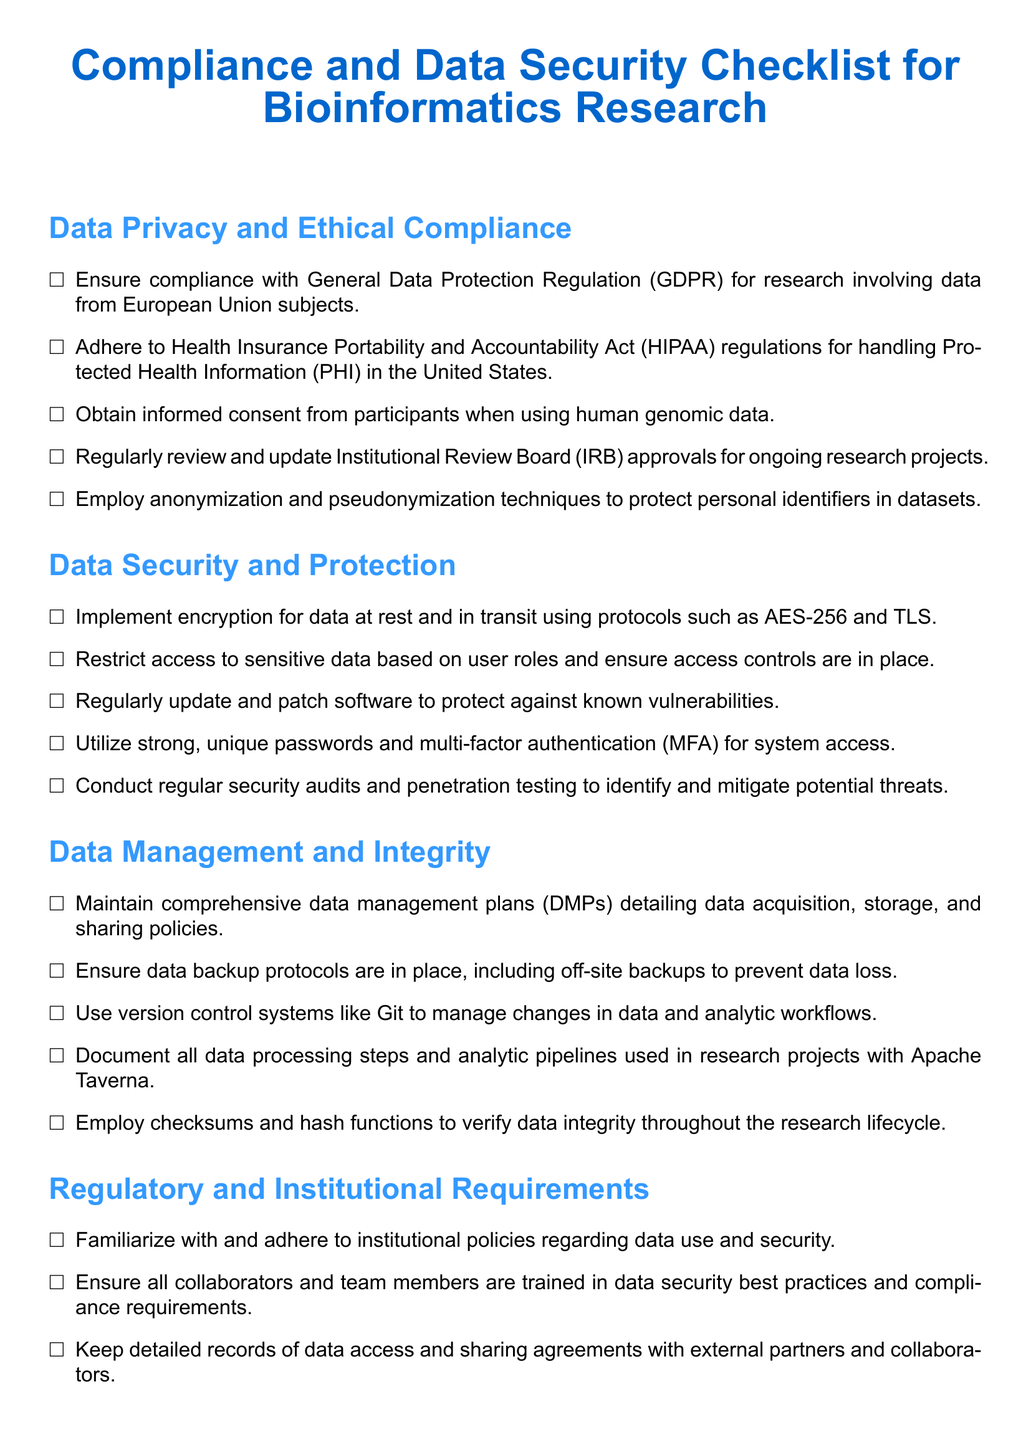What is the title of the document? The title of the document is prominently displayed and summarizes the importance of the content, which focuses on compliance and data security in bioinformatics research.
Answer: Compliance and Data Security Checklist for Bioinformatics Research What regulation must be followed for data from EU subjects? The document specifies the regulation that must be adhered to when using data from subjects in the European Union, which focuses on data privacy.
Answer: GDPR What security protocol is recommended for data in transit? The document includes a specific protocol that is advised for the protection of data while being transmitted from one location to another.
Answer: TLS Which enhancement is suggested for system access? The checklist recommends a security measure that adds an additional layer of security for accessing systems beyond just a password.
Answer: Multi-factor authentication (MFA) What should be implemented besides encryption? The document highlights additional measures that must be taken alongside encryption to enhance data security and limit access based on specific criteria.
Answer: Access controls How often should software be updated? The document emphasizes a crucial practice in maintaining software that protects against vulnerabilities, indicating a frequency for updates.
Answer: Regularly What is the purpose of employing checksums? The document states a specific use for checksums and hash functions within the data management process, especially related to data integrity.
Answer: Verify data integrity What needs to be maintained for data acquisition and sharing? The checklist indicates a essential documentation requirement that outlines policies for managing research data, covering various stages of data handling.
Answer: Data management plans (DMPs) What agency's policies should be regularly reviewed? The document advises on compliance with certain policies that govern the sharing and management of data related to funding.
Answer: Funding agency 